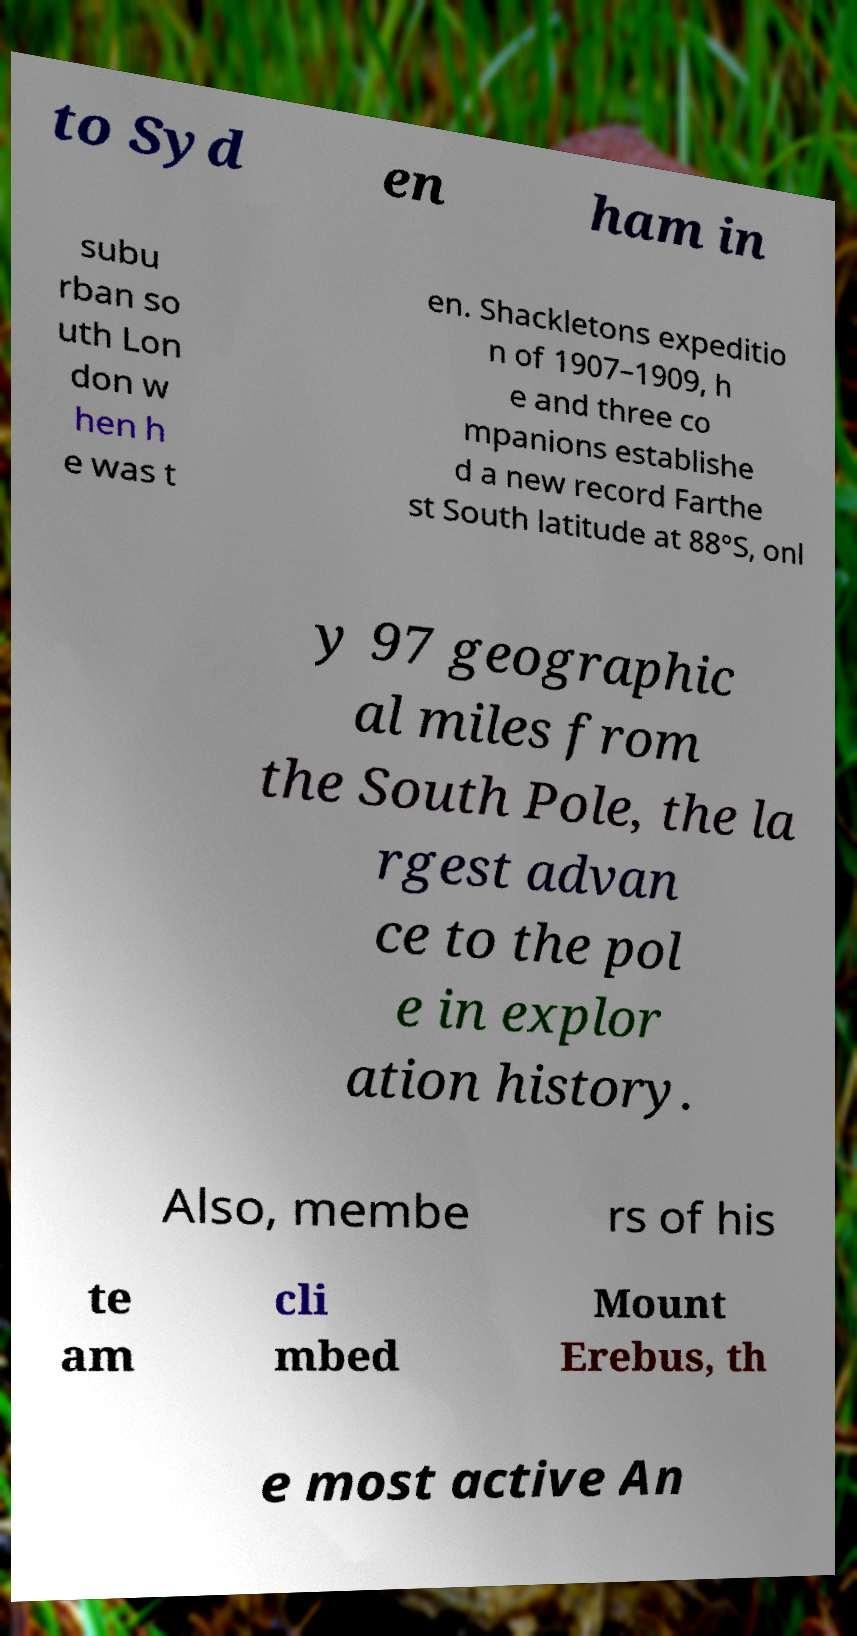Please identify and transcribe the text found in this image. to Syd en ham in subu rban so uth Lon don w hen h e was t en. Shackletons expeditio n of 1907–1909, h e and three co mpanions establishe d a new record Farthe st South latitude at 88°S, onl y 97 geographic al miles from the South Pole, the la rgest advan ce to the pol e in explor ation history. Also, membe rs of his te am cli mbed Mount Erebus, th e most active An 